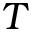Convert formula to latex. <formula><loc_0><loc_0><loc_500><loc_500>T</formula> 